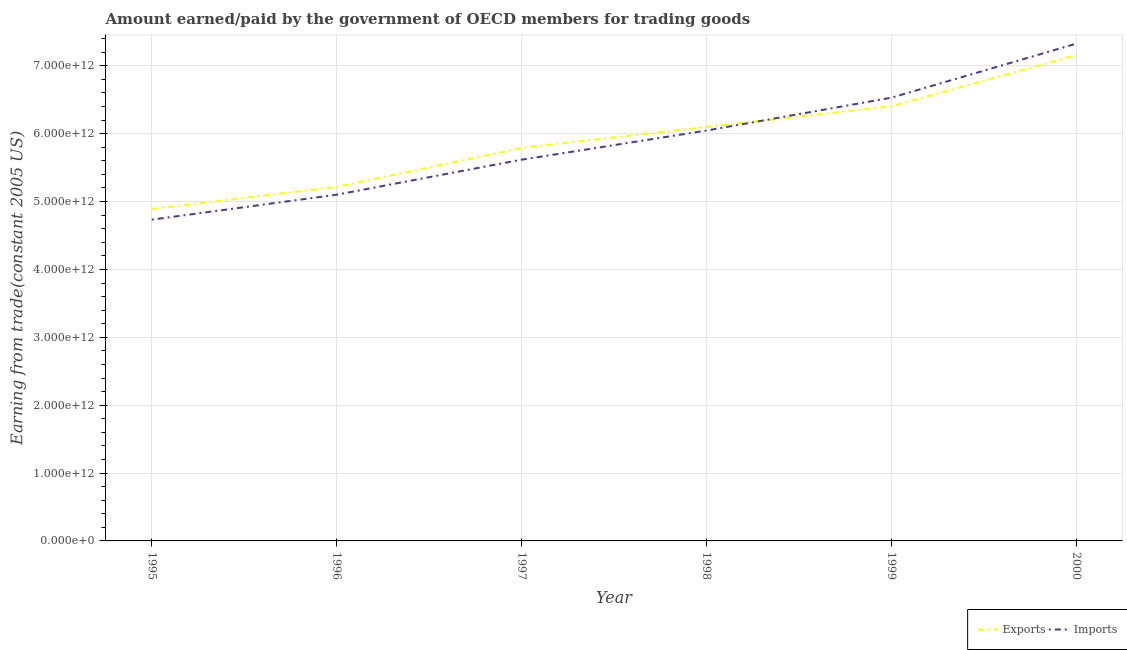Is the number of lines equal to the number of legend labels?
Your answer should be compact. Yes. What is the amount earned from exports in 1998?
Your response must be concise. 6.10e+12. Across all years, what is the maximum amount paid for imports?
Keep it short and to the point. 7.33e+12. Across all years, what is the minimum amount paid for imports?
Give a very brief answer. 4.73e+12. In which year was the amount paid for imports maximum?
Offer a very short reply. 2000. What is the total amount paid for imports in the graph?
Your answer should be compact. 3.54e+13. What is the difference between the amount paid for imports in 1996 and that in 1999?
Give a very brief answer. -1.43e+12. What is the difference between the amount earned from exports in 1998 and the amount paid for imports in 1996?
Give a very brief answer. 9.98e+11. What is the average amount paid for imports per year?
Offer a terse response. 5.89e+12. In the year 1997, what is the difference between the amount earned from exports and amount paid for imports?
Ensure brevity in your answer.  1.74e+11. In how many years, is the amount paid for imports greater than 3000000000000 US$?
Provide a short and direct response. 6. What is the ratio of the amount paid for imports in 1997 to that in 1999?
Keep it short and to the point. 0.86. Is the difference between the amount earned from exports in 1995 and 1999 greater than the difference between the amount paid for imports in 1995 and 1999?
Offer a very short reply. Yes. What is the difference between the highest and the second highest amount earned from exports?
Your response must be concise. 7.53e+11. What is the difference between the highest and the lowest amount paid for imports?
Your answer should be very brief. 2.59e+12. Does the amount paid for imports monotonically increase over the years?
Provide a succinct answer. Yes. Is the amount earned from exports strictly less than the amount paid for imports over the years?
Provide a succinct answer. No. How many lines are there?
Give a very brief answer. 2. How many years are there in the graph?
Make the answer very short. 6. What is the difference between two consecutive major ticks on the Y-axis?
Ensure brevity in your answer.  1.00e+12. Are the values on the major ticks of Y-axis written in scientific E-notation?
Offer a very short reply. Yes. Does the graph contain any zero values?
Make the answer very short. No. Does the graph contain grids?
Your response must be concise. Yes. How are the legend labels stacked?
Make the answer very short. Horizontal. What is the title of the graph?
Your response must be concise. Amount earned/paid by the government of OECD members for trading goods. Does "Tetanus" appear as one of the legend labels in the graph?
Provide a short and direct response. No. What is the label or title of the Y-axis?
Provide a succinct answer. Earning from trade(constant 2005 US). What is the Earning from trade(constant 2005 US) of Exports in 1995?
Your answer should be compact. 4.89e+12. What is the Earning from trade(constant 2005 US) of Imports in 1995?
Your answer should be compact. 4.73e+12. What is the Earning from trade(constant 2005 US) in Exports in 1996?
Make the answer very short. 5.22e+12. What is the Earning from trade(constant 2005 US) in Imports in 1996?
Your answer should be very brief. 5.10e+12. What is the Earning from trade(constant 2005 US) of Exports in 1997?
Provide a succinct answer. 5.79e+12. What is the Earning from trade(constant 2005 US) in Imports in 1997?
Ensure brevity in your answer.  5.62e+12. What is the Earning from trade(constant 2005 US) of Exports in 1998?
Your answer should be compact. 6.10e+12. What is the Earning from trade(constant 2005 US) in Imports in 1998?
Provide a succinct answer. 6.05e+12. What is the Earning from trade(constant 2005 US) in Exports in 1999?
Offer a very short reply. 6.40e+12. What is the Earning from trade(constant 2005 US) of Imports in 1999?
Your answer should be very brief. 6.53e+12. What is the Earning from trade(constant 2005 US) in Exports in 2000?
Your answer should be very brief. 7.16e+12. What is the Earning from trade(constant 2005 US) of Imports in 2000?
Your answer should be very brief. 7.33e+12. Across all years, what is the maximum Earning from trade(constant 2005 US) in Exports?
Offer a very short reply. 7.16e+12. Across all years, what is the maximum Earning from trade(constant 2005 US) in Imports?
Your response must be concise. 7.33e+12. Across all years, what is the minimum Earning from trade(constant 2005 US) in Exports?
Offer a terse response. 4.89e+12. Across all years, what is the minimum Earning from trade(constant 2005 US) in Imports?
Provide a succinct answer. 4.73e+12. What is the total Earning from trade(constant 2005 US) in Exports in the graph?
Offer a terse response. 3.56e+13. What is the total Earning from trade(constant 2005 US) in Imports in the graph?
Your response must be concise. 3.54e+13. What is the difference between the Earning from trade(constant 2005 US) in Exports in 1995 and that in 1996?
Your answer should be very brief. -3.25e+11. What is the difference between the Earning from trade(constant 2005 US) of Imports in 1995 and that in 1996?
Your response must be concise. -3.68e+11. What is the difference between the Earning from trade(constant 2005 US) of Exports in 1995 and that in 1997?
Offer a very short reply. -8.99e+11. What is the difference between the Earning from trade(constant 2005 US) of Imports in 1995 and that in 1997?
Ensure brevity in your answer.  -8.83e+11. What is the difference between the Earning from trade(constant 2005 US) in Exports in 1995 and that in 1998?
Provide a succinct answer. -1.21e+12. What is the difference between the Earning from trade(constant 2005 US) of Imports in 1995 and that in 1998?
Offer a very short reply. -1.31e+12. What is the difference between the Earning from trade(constant 2005 US) in Exports in 1995 and that in 1999?
Provide a succinct answer. -1.51e+12. What is the difference between the Earning from trade(constant 2005 US) of Imports in 1995 and that in 1999?
Ensure brevity in your answer.  -1.80e+12. What is the difference between the Earning from trade(constant 2005 US) of Exports in 1995 and that in 2000?
Your answer should be compact. -2.27e+12. What is the difference between the Earning from trade(constant 2005 US) in Imports in 1995 and that in 2000?
Give a very brief answer. -2.59e+12. What is the difference between the Earning from trade(constant 2005 US) in Exports in 1996 and that in 1997?
Ensure brevity in your answer.  -5.75e+11. What is the difference between the Earning from trade(constant 2005 US) in Imports in 1996 and that in 1997?
Ensure brevity in your answer.  -5.16e+11. What is the difference between the Earning from trade(constant 2005 US) of Exports in 1996 and that in 1998?
Make the answer very short. -8.83e+11. What is the difference between the Earning from trade(constant 2005 US) of Imports in 1996 and that in 1998?
Give a very brief answer. -9.45e+11. What is the difference between the Earning from trade(constant 2005 US) in Exports in 1996 and that in 1999?
Make the answer very short. -1.19e+12. What is the difference between the Earning from trade(constant 2005 US) of Imports in 1996 and that in 1999?
Your answer should be compact. -1.43e+12. What is the difference between the Earning from trade(constant 2005 US) in Exports in 1996 and that in 2000?
Provide a succinct answer. -1.94e+12. What is the difference between the Earning from trade(constant 2005 US) in Imports in 1996 and that in 2000?
Provide a short and direct response. -2.23e+12. What is the difference between the Earning from trade(constant 2005 US) of Exports in 1997 and that in 1998?
Your response must be concise. -3.09e+11. What is the difference between the Earning from trade(constant 2005 US) in Imports in 1997 and that in 1998?
Ensure brevity in your answer.  -4.29e+11. What is the difference between the Earning from trade(constant 2005 US) of Exports in 1997 and that in 1999?
Your response must be concise. -6.13e+11. What is the difference between the Earning from trade(constant 2005 US) in Imports in 1997 and that in 1999?
Offer a very short reply. -9.14e+11. What is the difference between the Earning from trade(constant 2005 US) in Exports in 1997 and that in 2000?
Offer a very short reply. -1.37e+12. What is the difference between the Earning from trade(constant 2005 US) in Imports in 1997 and that in 2000?
Make the answer very short. -1.71e+12. What is the difference between the Earning from trade(constant 2005 US) of Exports in 1998 and that in 1999?
Offer a very short reply. -3.05e+11. What is the difference between the Earning from trade(constant 2005 US) in Imports in 1998 and that in 1999?
Make the answer very short. -4.85e+11. What is the difference between the Earning from trade(constant 2005 US) in Exports in 1998 and that in 2000?
Give a very brief answer. -1.06e+12. What is the difference between the Earning from trade(constant 2005 US) of Imports in 1998 and that in 2000?
Your response must be concise. -1.28e+12. What is the difference between the Earning from trade(constant 2005 US) in Exports in 1999 and that in 2000?
Ensure brevity in your answer.  -7.53e+11. What is the difference between the Earning from trade(constant 2005 US) of Imports in 1999 and that in 2000?
Provide a succinct answer. -7.96e+11. What is the difference between the Earning from trade(constant 2005 US) of Exports in 1995 and the Earning from trade(constant 2005 US) of Imports in 1996?
Give a very brief answer. -2.10e+11. What is the difference between the Earning from trade(constant 2005 US) of Exports in 1995 and the Earning from trade(constant 2005 US) of Imports in 1997?
Keep it short and to the point. -7.26e+11. What is the difference between the Earning from trade(constant 2005 US) in Exports in 1995 and the Earning from trade(constant 2005 US) in Imports in 1998?
Give a very brief answer. -1.15e+12. What is the difference between the Earning from trade(constant 2005 US) in Exports in 1995 and the Earning from trade(constant 2005 US) in Imports in 1999?
Offer a terse response. -1.64e+12. What is the difference between the Earning from trade(constant 2005 US) in Exports in 1995 and the Earning from trade(constant 2005 US) in Imports in 2000?
Keep it short and to the point. -2.43e+12. What is the difference between the Earning from trade(constant 2005 US) of Exports in 1996 and the Earning from trade(constant 2005 US) of Imports in 1997?
Provide a succinct answer. -4.01e+11. What is the difference between the Earning from trade(constant 2005 US) of Exports in 1996 and the Earning from trade(constant 2005 US) of Imports in 1998?
Keep it short and to the point. -8.30e+11. What is the difference between the Earning from trade(constant 2005 US) in Exports in 1996 and the Earning from trade(constant 2005 US) in Imports in 1999?
Your answer should be very brief. -1.31e+12. What is the difference between the Earning from trade(constant 2005 US) of Exports in 1996 and the Earning from trade(constant 2005 US) of Imports in 2000?
Your response must be concise. -2.11e+12. What is the difference between the Earning from trade(constant 2005 US) of Exports in 1997 and the Earning from trade(constant 2005 US) of Imports in 1998?
Keep it short and to the point. -2.55e+11. What is the difference between the Earning from trade(constant 2005 US) in Exports in 1997 and the Earning from trade(constant 2005 US) in Imports in 1999?
Ensure brevity in your answer.  -7.40e+11. What is the difference between the Earning from trade(constant 2005 US) in Exports in 1997 and the Earning from trade(constant 2005 US) in Imports in 2000?
Give a very brief answer. -1.54e+12. What is the difference between the Earning from trade(constant 2005 US) of Exports in 1998 and the Earning from trade(constant 2005 US) of Imports in 1999?
Your answer should be very brief. -4.31e+11. What is the difference between the Earning from trade(constant 2005 US) of Exports in 1998 and the Earning from trade(constant 2005 US) of Imports in 2000?
Ensure brevity in your answer.  -1.23e+12. What is the difference between the Earning from trade(constant 2005 US) of Exports in 1999 and the Earning from trade(constant 2005 US) of Imports in 2000?
Offer a terse response. -9.22e+11. What is the average Earning from trade(constant 2005 US) of Exports per year?
Make the answer very short. 5.93e+12. What is the average Earning from trade(constant 2005 US) in Imports per year?
Ensure brevity in your answer.  5.89e+12. In the year 1995, what is the difference between the Earning from trade(constant 2005 US) in Exports and Earning from trade(constant 2005 US) in Imports?
Provide a succinct answer. 1.58e+11. In the year 1996, what is the difference between the Earning from trade(constant 2005 US) of Exports and Earning from trade(constant 2005 US) of Imports?
Make the answer very short. 1.15e+11. In the year 1997, what is the difference between the Earning from trade(constant 2005 US) of Exports and Earning from trade(constant 2005 US) of Imports?
Provide a succinct answer. 1.74e+11. In the year 1998, what is the difference between the Earning from trade(constant 2005 US) in Exports and Earning from trade(constant 2005 US) in Imports?
Ensure brevity in your answer.  5.31e+1. In the year 1999, what is the difference between the Earning from trade(constant 2005 US) in Exports and Earning from trade(constant 2005 US) in Imports?
Give a very brief answer. -1.27e+11. In the year 2000, what is the difference between the Earning from trade(constant 2005 US) of Exports and Earning from trade(constant 2005 US) of Imports?
Offer a terse response. -1.70e+11. What is the ratio of the Earning from trade(constant 2005 US) in Exports in 1995 to that in 1996?
Provide a succinct answer. 0.94. What is the ratio of the Earning from trade(constant 2005 US) in Imports in 1995 to that in 1996?
Offer a terse response. 0.93. What is the ratio of the Earning from trade(constant 2005 US) of Exports in 1995 to that in 1997?
Make the answer very short. 0.84. What is the ratio of the Earning from trade(constant 2005 US) in Imports in 1995 to that in 1997?
Provide a succinct answer. 0.84. What is the ratio of the Earning from trade(constant 2005 US) of Exports in 1995 to that in 1998?
Ensure brevity in your answer.  0.8. What is the ratio of the Earning from trade(constant 2005 US) of Imports in 1995 to that in 1998?
Your answer should be very brief. 0.78. What is the ratio of the Earning from trade(constant 2005 US) of Exports in 1995 to that in 1999?
Offer a terse response. 0.76. What is the ratio of the Earning from trade(constant 2005 US) of Imports in 1995 to that in 1999?
Offer a terse response. 0.72. What is the ratio of the Earning from trade(constant 2005 US) of Exports in 1995 to that in 2000?
Offer a terse response. 0.68. What is the ratio of the Earning from trade(constant 2005 US) of Imports in 1995 to that in 2000?
Ensure brevity in your answer.  0.65. What is the ratio of the Earning from trade(constant 2005 US) in Exports in 1996 to that in 1997?
Keep it short and to the point. 0.9. What is the ratio of the Earning from trade(constant 2005 US) in Imports in 1996 to that in 1997?
Give a very brief answer. 0.91. What is the ratio of the Earning from trade(constant 2005 US) in Exports in 1996 to that in 1998?
Offer a terse response. 0.86. What is the ratio of the Earning from trade(constant 2005 US) of Imports in 1996 to that in 1998?
Provide a short and direct response. 0.84. What is the ratio of the Earning from trade(constant 2005 US) in Exports in 1996 to that in 1999?
Provide a succinct answer. 0.81. What is the ratio of the Earning from trade(constant 2005 US) in Imports in 1996 to that in 1999?
Give a very brief answer. 0.78. What is the ratio of the Earning from trade(constant 2005 US) of Exports in 1996 to that in 2000?
Make the answer very short. 0.73. What is the ratio of the Earning from trade(constant 2005 US) of Imports in 1996 to that in 2000?
Ensure brevity in your answer.  0.7. What is the ratio of the Earning from trade(constant 2005 US) of Exports in 1997 to that in 1998?
Give a very brief answer. 0.95. What is the ratio of the Earning from trade(constant 2005 US) of Imports in 1997 to that in 1998?
Ensure brevity in your answer.  0.93. What is the ratio of the Earning from trade(constant 2005 US) in Exports in 1997 to that in 1999?
Make the answer very short. 0.9. What is the ratio of the Earning from trade(constant 2005 US) of Imports in 1997 to that in 1999?
Give a very brief answer. 0.86. What is the ratio of the Earning from trade(constant 2005 US) in Exports in 1997 to that in 2000?
Your answer should be compact. 0.81. What is the ratio of the Earning from trade(constant 2005 US) of Imports in 1997 to that in 2000?
Provide a short and direct response. 0.77. What is the ratio of the Earning from trade(constant 2005 US) of Exports in 1998 to that in 1999?
Your answer should be very brief. 0.95. What is the ratio of the Earning from trade(constant 2005 US) of Imports in 1998 to that in 1999?
Your response must be concise. 0.93. What is the ratio of the Earning from trade(constant 2005 US) in Exports in 1998 to that in 2000?
Keep it short and to the point. 0.85. What is the ratio of the Earning from trade(constant 2005 US) of Imports in 1998 to that in 2000?
Ensure brevity in your answer.  0.83. What is the ratio of the Earning from trade(constant 2005 US) in Exports in 1999 to that in 2000?
Give a very brief answer. 0.89. What is the ratio of the Earning from trade(constant 2005 US) in Imports in 1999 to that in 2000?
Provide a short and direct response. 0.89. What is the difference between the highest and the second highest Earning from trade(constant 2005 US) of Exports?
Give a very brief answer. 7.53e+11. What is the difference between the highest and the second highest Earning from trade(constant 2005 US) of Imports?
Your answer should be compact. 7.96e+11. What is the difference between the highest and the lowest Earning from trade(constant 2005 US) in Exports?
Offer a terse response. 2.27e+12. What is the difference between the highest and the lowest Earning from trade(constant 2005 US) in Imports?
Offer a very short reply. 2.59e+12. 